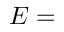<formula> <loc_0><loc_0><loc_500><loc_500>E =</formula> 